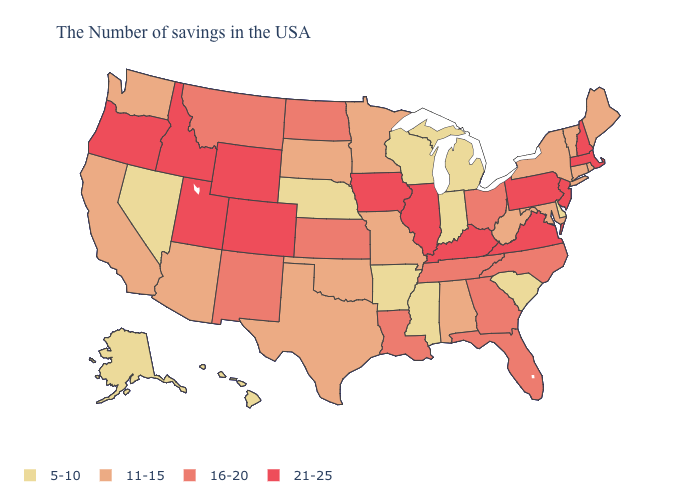Which states have the highest value in the USA?
Quick response, please. Massachusetts, New Hampshire, New Jersey, Pennsylvania, Virginia, Kentucky, Illinois, Iowa, Wyoming, Colorado, Utah, Idaho, Oregon. Among the states that border Iowa , which have the lowest value?
Answer briefly. Wisconsin, Nebraska. Does the map have missing data?
Short answer required. No. What is the value of West Virginia?
Write a very short answer. 11-15. Name the states that have a value in the range 5-10?
Short answer required. Delaware, South Carolina, Michigan, Indiana, Wisconsin, Mississippi, Arkansas, Nebraska, Nevada, Alaska, Hawaii. Name the states that have a value in the range 5-10?
Be succinct. Delaware, South Carolina, Michigan, Indiana, Wisconsin, Mississippi, Arkansas, Nebraska, Nevada, Alaska, Hawaii. Name the states that have a value in the range 11-15?
Give a very brief answer. Maine, Rhode Island, Vermont, Connecticut, New York, Maryland, West Virginia, Alabama, Missouri, Minnesota, Oklahoma, Texas, South Dakota, Arizona, California, Washington. Does Idaho have the same value as Wisconsin?
Quick response, please. No. What is the value of Wyoming?
Keep it brief. 21-25. Does Missouri have a lower value than Oklahoma?
Answer briefly. No. Name the states that have a value in the range 11-15?
Keep it brief. Maine, Rhode Island, Vermont, Connecticut, New York, Maryland, West Virginia, Alabama, Missouri, Minnesota, Oklahoma, Texas, South Dakota, Arizona, California, Washington. What is the lowest value in the Northeast?
Be succinct. 11-15. Name the states that have a value in the range 5-10?
Give a very brief answer. Delaware, South Carolina, Michigan, Indiana, Wisconsin, Mississippi, Arkansas, Nebraska, Nevada, Alaska, Hawaii. Name the states that have a value in the range 16-20?
Answer briefly. North Carolina, Ohio, Florida, Georgia, Tennessee, Louisiana, Kansas, North Dakota, New Mexico, Montana. Among the states that border Nevada , does Utah have the lowest value?
Give a very brief answer. No. 